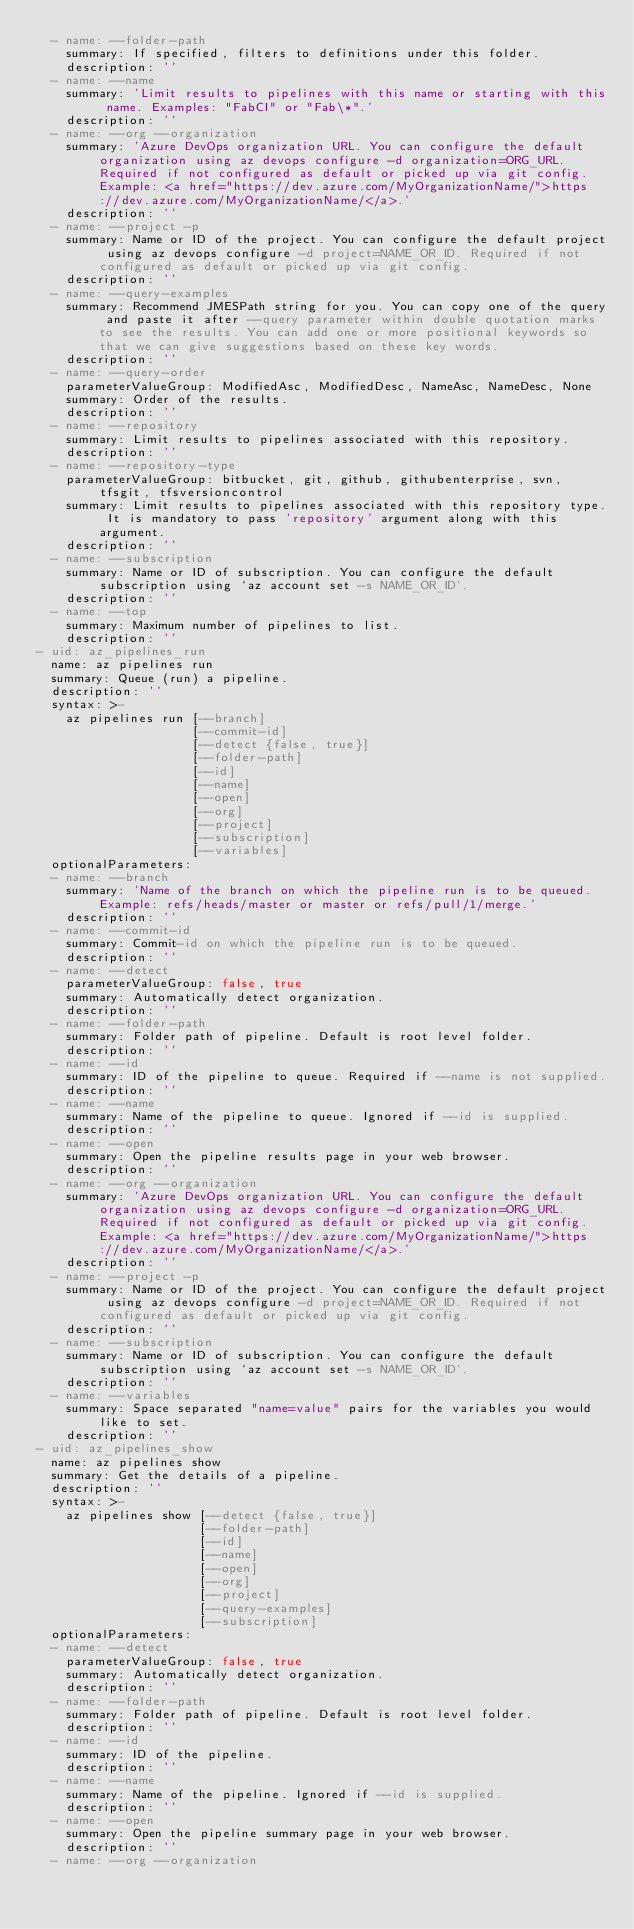Convert code to text. <code><loc_0><loc_0><loc_500><loc_500><_YAML_>  - name: --folder-path
    summary: If specified, filters to definitions under this folder.
    description: ''
  - name: --name
    summary: 'Limit results to pipelines with this name or starting with this name. Examples: "FabCI" or "Fab\*".'
    description: ''
  - name: --org --organization
    summary: 'Azure DevOps organization URL. You can configure the default organization using az devops configure -d organization=ORG_URL. Required if not configured as default or picked up via git config. Example: <a href="https://dev.azure.com/MyOrganizationName/">https://dev.azure.com/MyOrganizationName/</a>.'
    description: ''
  - name: --project -p
    summary: Name or ID of the project. You can configure the default project using az devops configure -d project=NAME_OR_ID. Required if not configured as default or picked up via git config.
    description: ''
  - name: --query-examples
    summary: Recommend JMESPath string for you. You can copy one of the query and paste it after --query parameter within double quotation marks to see the results. You can add one or more positional keywords so that we can give suggestions based on these key words.
    description: ''
  - name: --query-order
    parameterValueGroup: ModifiedAsc, ModifiedDesc, NameAsc, NameDesc, None
    summary: Order of the results.
    description: ''
  - name: --repository
    summary: Limit results to pipelines associated with this repository.
    description: ''
  - name: --repository-type
    parameterValueGroup: bitbucket, git, github, githubenterprise, svn, tfsgit, tfsversioncontrol
    summary: Limit results to pipelines associated with this repository type. It is mandatory to pass 'repository' argument along with this argument.
    description: ''
  - name: --subscription
    summary: Name or ID of subscription. You can configure the default subscription using `az account set -s NAME_OR_ID`.
    description: ''
  - name: --top
    summary: Maximum number of pipelines to list.
    description: ''
- uid: az_pipelines_run
  name: az pipelines run
  summary: Queue (run) a pipeline.
  description: ''
  syntax: >-
    az pipelines run [--branch]
                     [--commit-id]
                     [--detect {false, true}]
                     [--folder-path]
                     [--id]
                     [--name]
                     [--open]
                     [--org]
                     [--project]
                     [--subscription]
                     [--variables]
  optionalParameters:
  - name: --branch
    summary: 'Name of the branch on which the pipeline run is to be queued. Example: refs/heads/master or master or refs/pull/1/merge.'
    description: ''
  - name: --commit-id
    summary: Commit-id on which the pipeline run is to be queued.
    description: ''
  - name: --detect
    parameterValueGroup: false, true
    summary: Automatically detect organization.
    description: ''
  - name: --folder-path
    summary: Folder path of pipeline. Default is root level folder.
    description: ''
  - name: --id
    summary: ID of the pipeline to queue. Required if --name is not supplied.
    description: ''
  - name: --name
    summary: Name of the pipeline to queue. Ignored if --id is supplied.
    description: ''
  - name: --open
    summary: Open the pipeline results page in your web browser.
    description: ''
  - name: --org --organization
    summary: 'Azure DevOps organization URL. You can configure the default organization using az devops configure -d organization=ORG_URL. Required if not configured as default or picked up via git config. Example: <a href="https://dev.azure.com/MyOrganizationName/">https://dev.azure.com/MyOrganizationName/</a>.'
    description: ''
  - name: --project -p
    summary: Name or ID of the project. You can configure the default project using az devops configure -d project=NAME_OR_ID. Required if not configured as default or picked up via git config.
    description: ''
  - name: --subscription
    summary: Name or ID of subscription. You can configure the default subscription using `az account set -s NAME_OR_ID`.
    description: ''
  - name: --variables
    summary: Space separated "name=value" pairs for the variables you would like to set.
    description: ''
- uid: az_pipelines_show
  name: az pipelines show
  summary: Get the details of a pipeline.
  description: ''
  syntax: >-
    az pipelines show [--detect {false, true}]
                      [--folder-path]
                      [--id]
                      [--name]
                      [--open]
                      [--org]
                      [--project]
                      [--query-examples]
                      [--subscription]
  optionalParameters:
  - name: --detect
    parameterValueGroup: false, true
    summary: Automatically detect organization.
    description: ''
  - name: --folder-path
    summary: Folder path of pipeline. Default is root level folder.
    description: ''
  - name: --id
    summary: ID of the pipeline.
    description: ''
  - name: --name
    summary: Name of the pipeline. Ignored if --id is supplied.
    description: ''
  - name: --open
    summary: Open the pipeline summary page in your web browser.
    description: ''
  - name: --org --organization</code> 